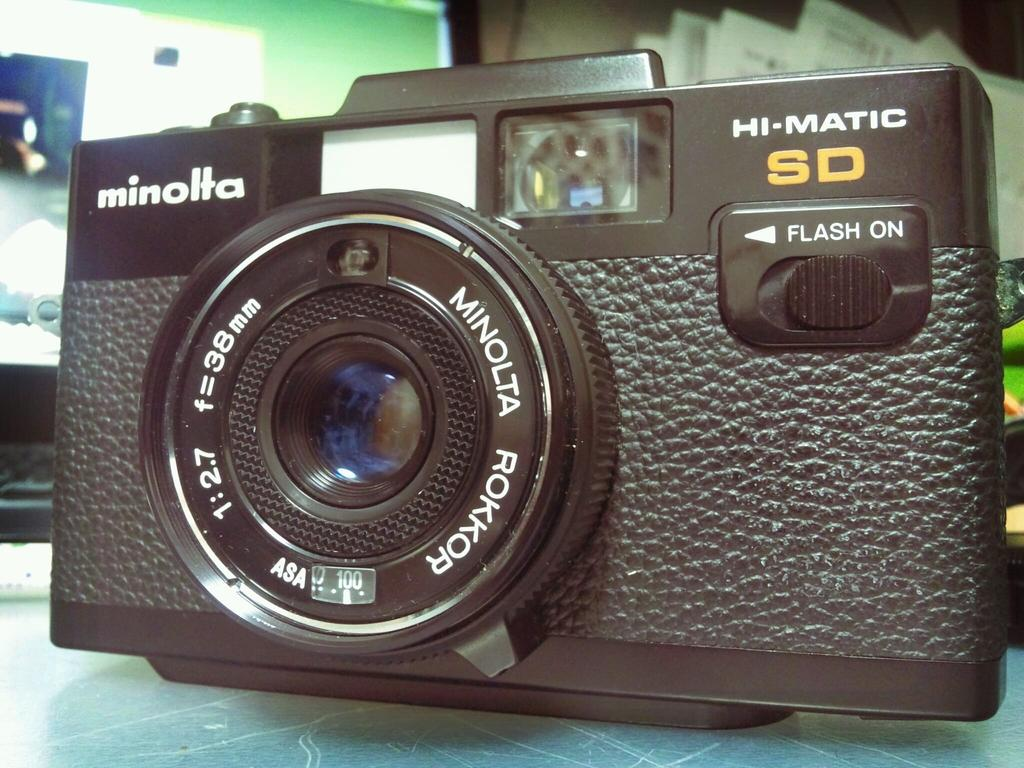What object is the main subject of the image? There is a black color camera in the image. Where is the camera located in the image? The camera is placed on a table. What can be seen in the background of the image? There is a green color wall in the background of the image. What type of food is being prepared on the table in the image? There is no food or preparation of food visible in the image; it features a black color camera placed on a table with a green color wall in the background. 